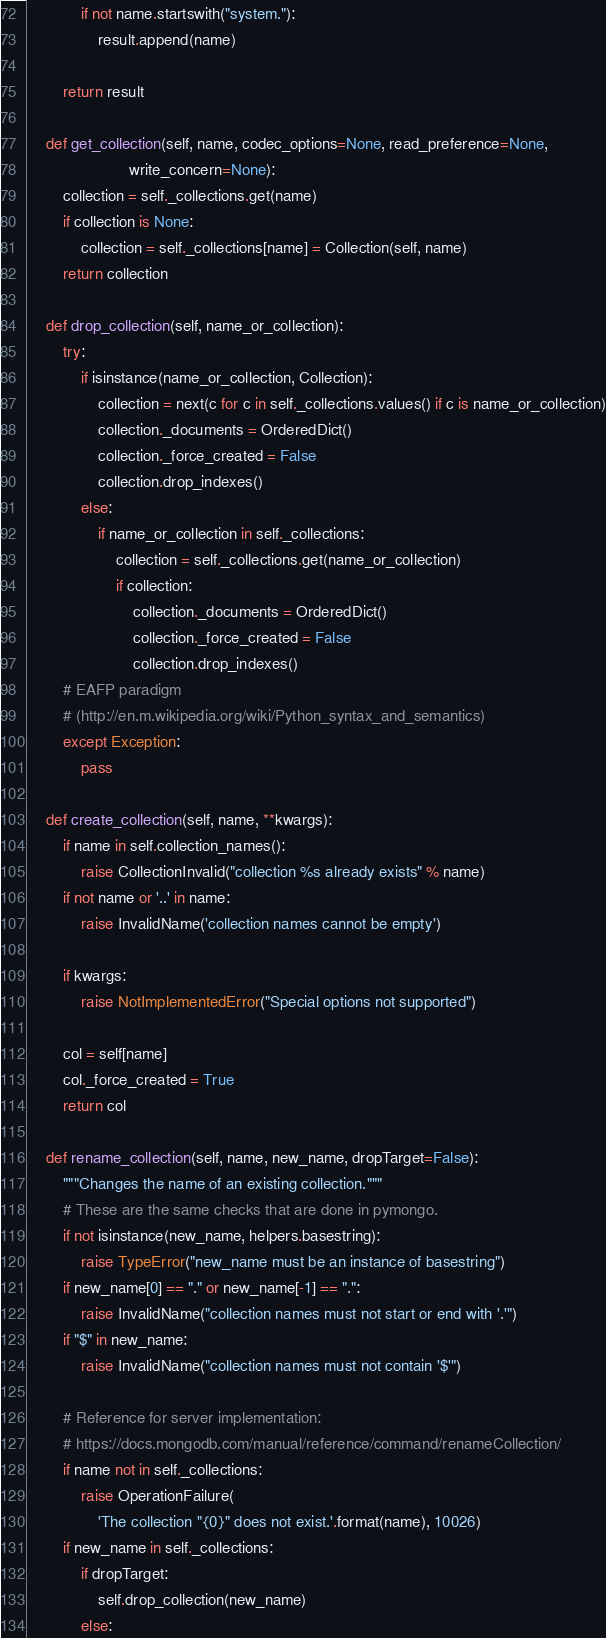<code> <loc_0><loc_0><loc_500><loc_500><_Python_>            if not name.startswith("system."):
                result.append(name)

        return result

    def get_collection(self, name, codec_options=None, read_preference=None,
                       write_concern=None):
        collection = self._collections.get(name)
        if collection is None:
            collection = self._collections[name] = Collection(self, name)
        return collection

    def drop_collection(self, name_or_collection):
        try:
            if isinstance(name_or_collection, Collection):
                collection = next(c for c in self._collections.values() if c is name_or_collection)
                collection._documents = OrderedDict()
                collection._force_created = False
                collection.drop_indexes()
            else:
                if name_or_collection in self._collections:
                    collection = self._collections.get(name_or_collection)
                    if collection:
                        collection._documents = OrderedDict()
                        collection._force_created = False
                        collection.drop_indexes()
        # EAFP paradigm
        # (http://en.m.wikipedia.org/wiki/Python_syntax_and_semantics)
        except Exception:
            pass

    def create_collection(self, name, **kwargs):
        if name in self.collection_names():
            raise CollectionInvalid("collection %s already exists" % name)
        if not name or '..' in name:
            raise InvalidName('collection names cannot be empty')

        if kwargs:
            raise NotImplementedError("Special options not supported")

        col = self[name]
        col._force_created = True
        return col

    def rename_collection(self, name, new_name, dropTarget=False):
        """Changes the name of an existing collection."""
        # These are the same checks that are done in pymongo.
        if not isinstance(new_name, helpers.basestring):
            raise TypeError("new_name must be an instance of basestring")
        if new_name[0] == "." or new_name[-1] == ".":
            raise InvalidName("collection names must not start or end with '.'")
        if "$" in new_name:
            raise InvalidName("collection names must not contain '$'")

        # Reference for server implementation:
        # https://docs.mongodb.com/manual/reference/command/renameCollection/
        if name not in self._collections:
            raise OperationFailure(
                'The collection "{0}" does not exist.'.format(name), 10026)
        if new_name in self._collections:
            if dropTarget:
                self.drop_collection(new_name)
            else:</code> 